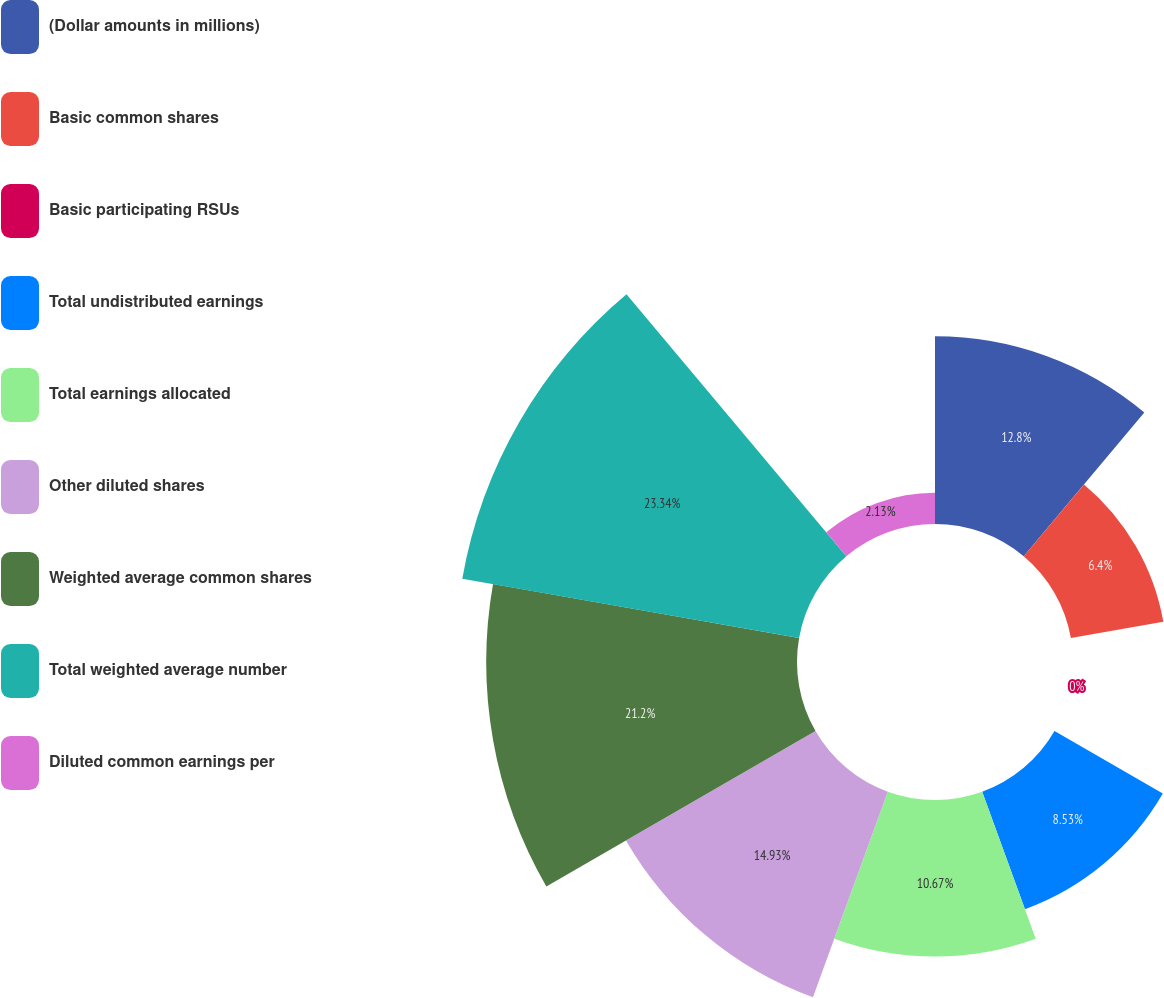Convert chart to OTSL. <chart><loc_0><loc_0><loc_500><loc_500><pie_chart><fcel>(Dollar amounts in millions)<fcel>Basic common shares<fcel>Basic participating RSUs<fcel>Total undistributed earnings<fcel>Total earnings allocated<fcel>Other diluted shares<fcel>Weighted average common shares<fcel>Total weighted average number<fcel>Diluted common earnings per<nl><fcel>12.8%<fcel>6.4%<fcel>0.0%<fcel>8.53%<fcel>10.67%<fcel>14.93%<fcel>21.2%<fcel>23.33%<fcel>2.13%<nl></chart> 